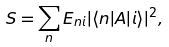Convert formula to latex. <formula><loc_0><loc_0><loc_500><loc_500>S = \sum _ { n } E _ { n i } | \langle n | A | i \rangle | ^ { 2 } ,</formula> 